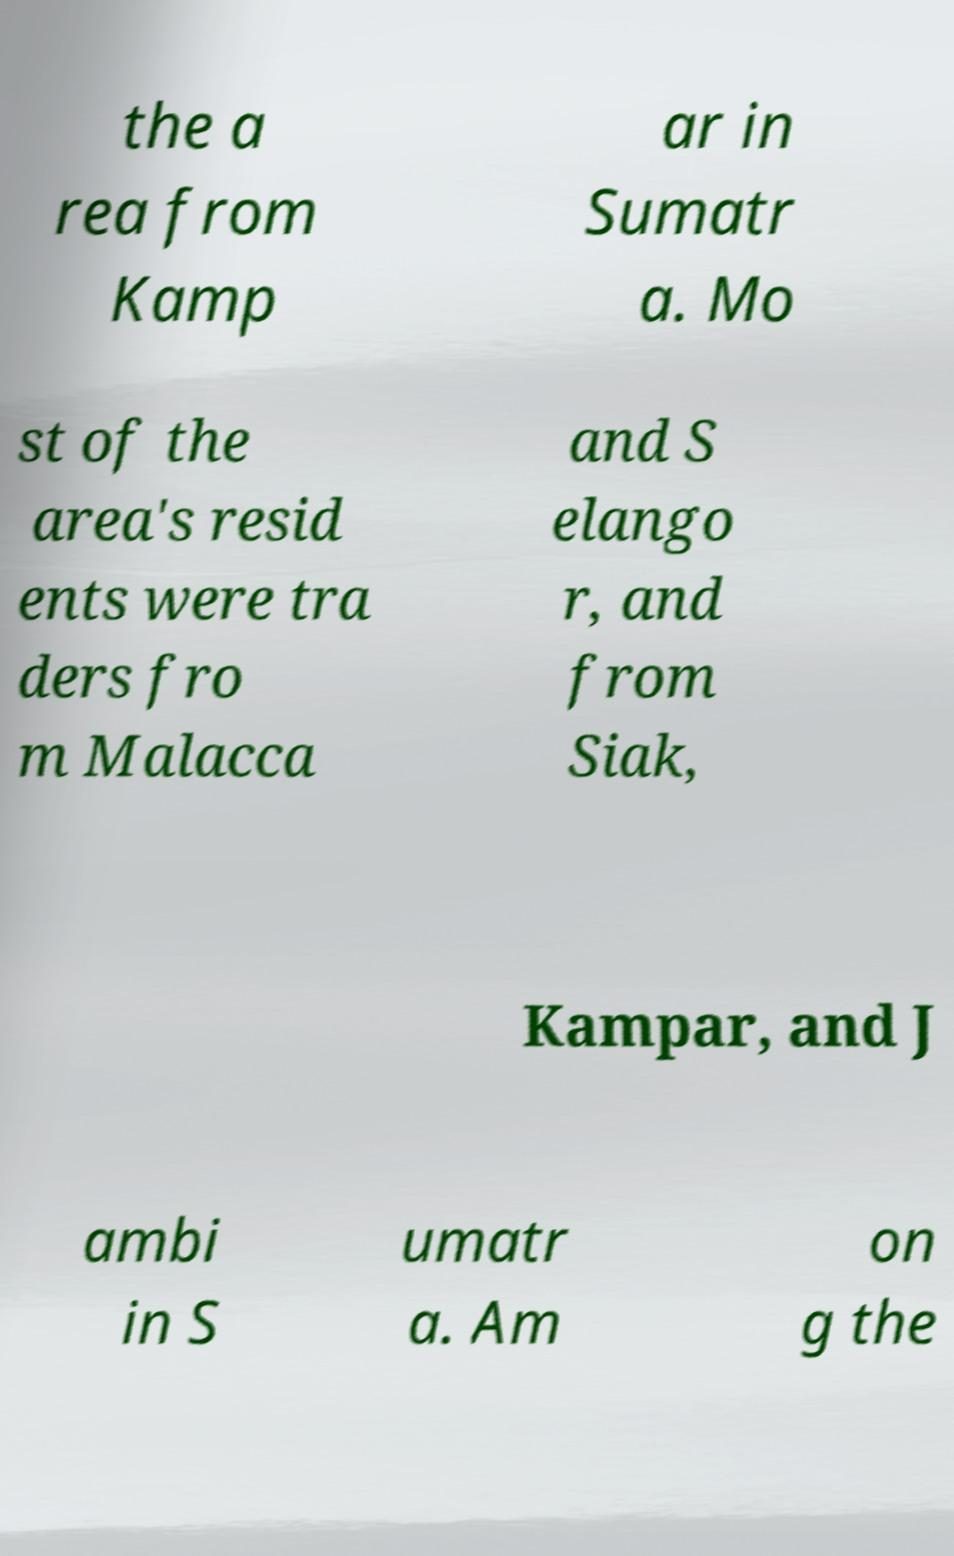Could you assist in decoding the text presented in this image and type it out clearly? the a rea from Kamp ar in Sumatr a. Mo st of the area's resid ents were tra ders fro m Malacca and S elango r, and from Siak, Kampar, and J ambi in S umatr a. Am on g the 